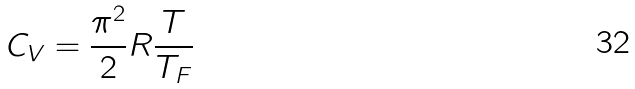<formula> <loc_0><loc_0><loc_500><loc_500>C _ { V } = \frac { \pi ^ { 2 } } { 2 } R \frac { T } { T _ { F } }</formula> 